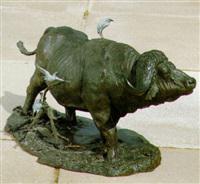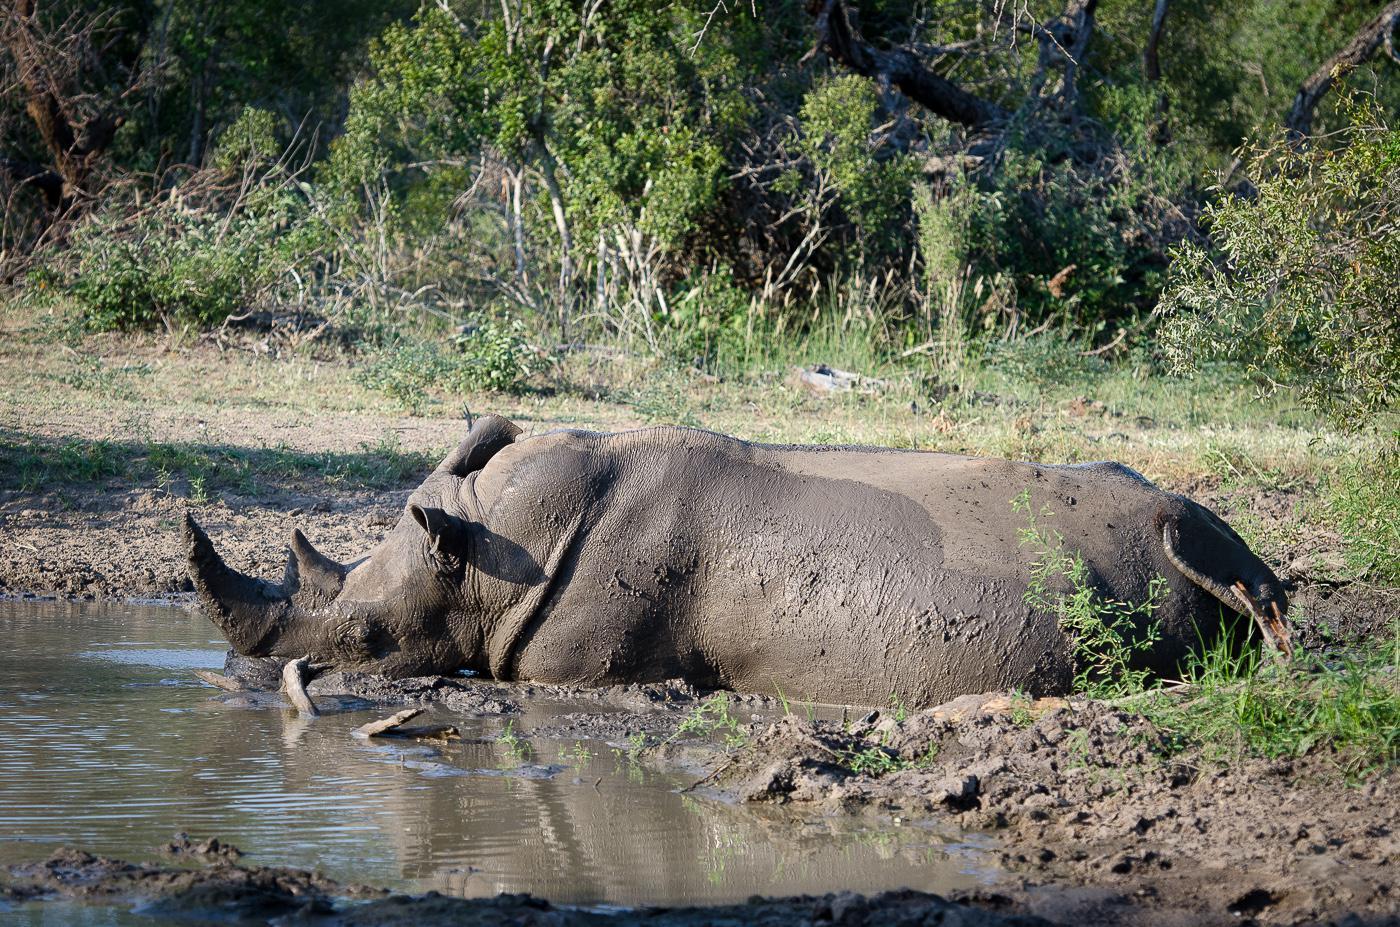The first image is the image on the left, the second image is the image on the right. Assess this claim about the two images: "The left image contains a water buffalo with a bird standing on its back.". Correct or not? Answer yes or no. Yes. The first image is the image on the left, the second image is the image on the right. Assess this claim about the two images: "The left image contains a sculpture of a water buffalo.". Correct or not? Answer yes or no. Yes. 